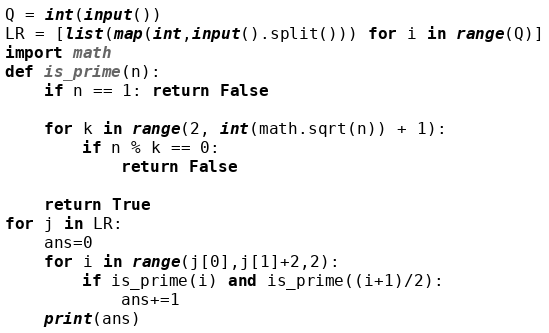<code> <loc_0><loc_0><loc_500><loc_500><_Python_>Q = int(input())
LR = [list(map(int,input().split())) for i in range(Q)]
import math
def is_prime(n):
    if n == 1: return False

    for k in range(2, int(math.sqrt(n)) + 1):
        if n % k == 0:
            return False

    return True
for j in LR:
    ans=0
    for i in range(j[0],j[1]+2,2):
        if is_prime(i) and is_prime((i+1)/2):
            ans+=1
    print(ans)</code> 